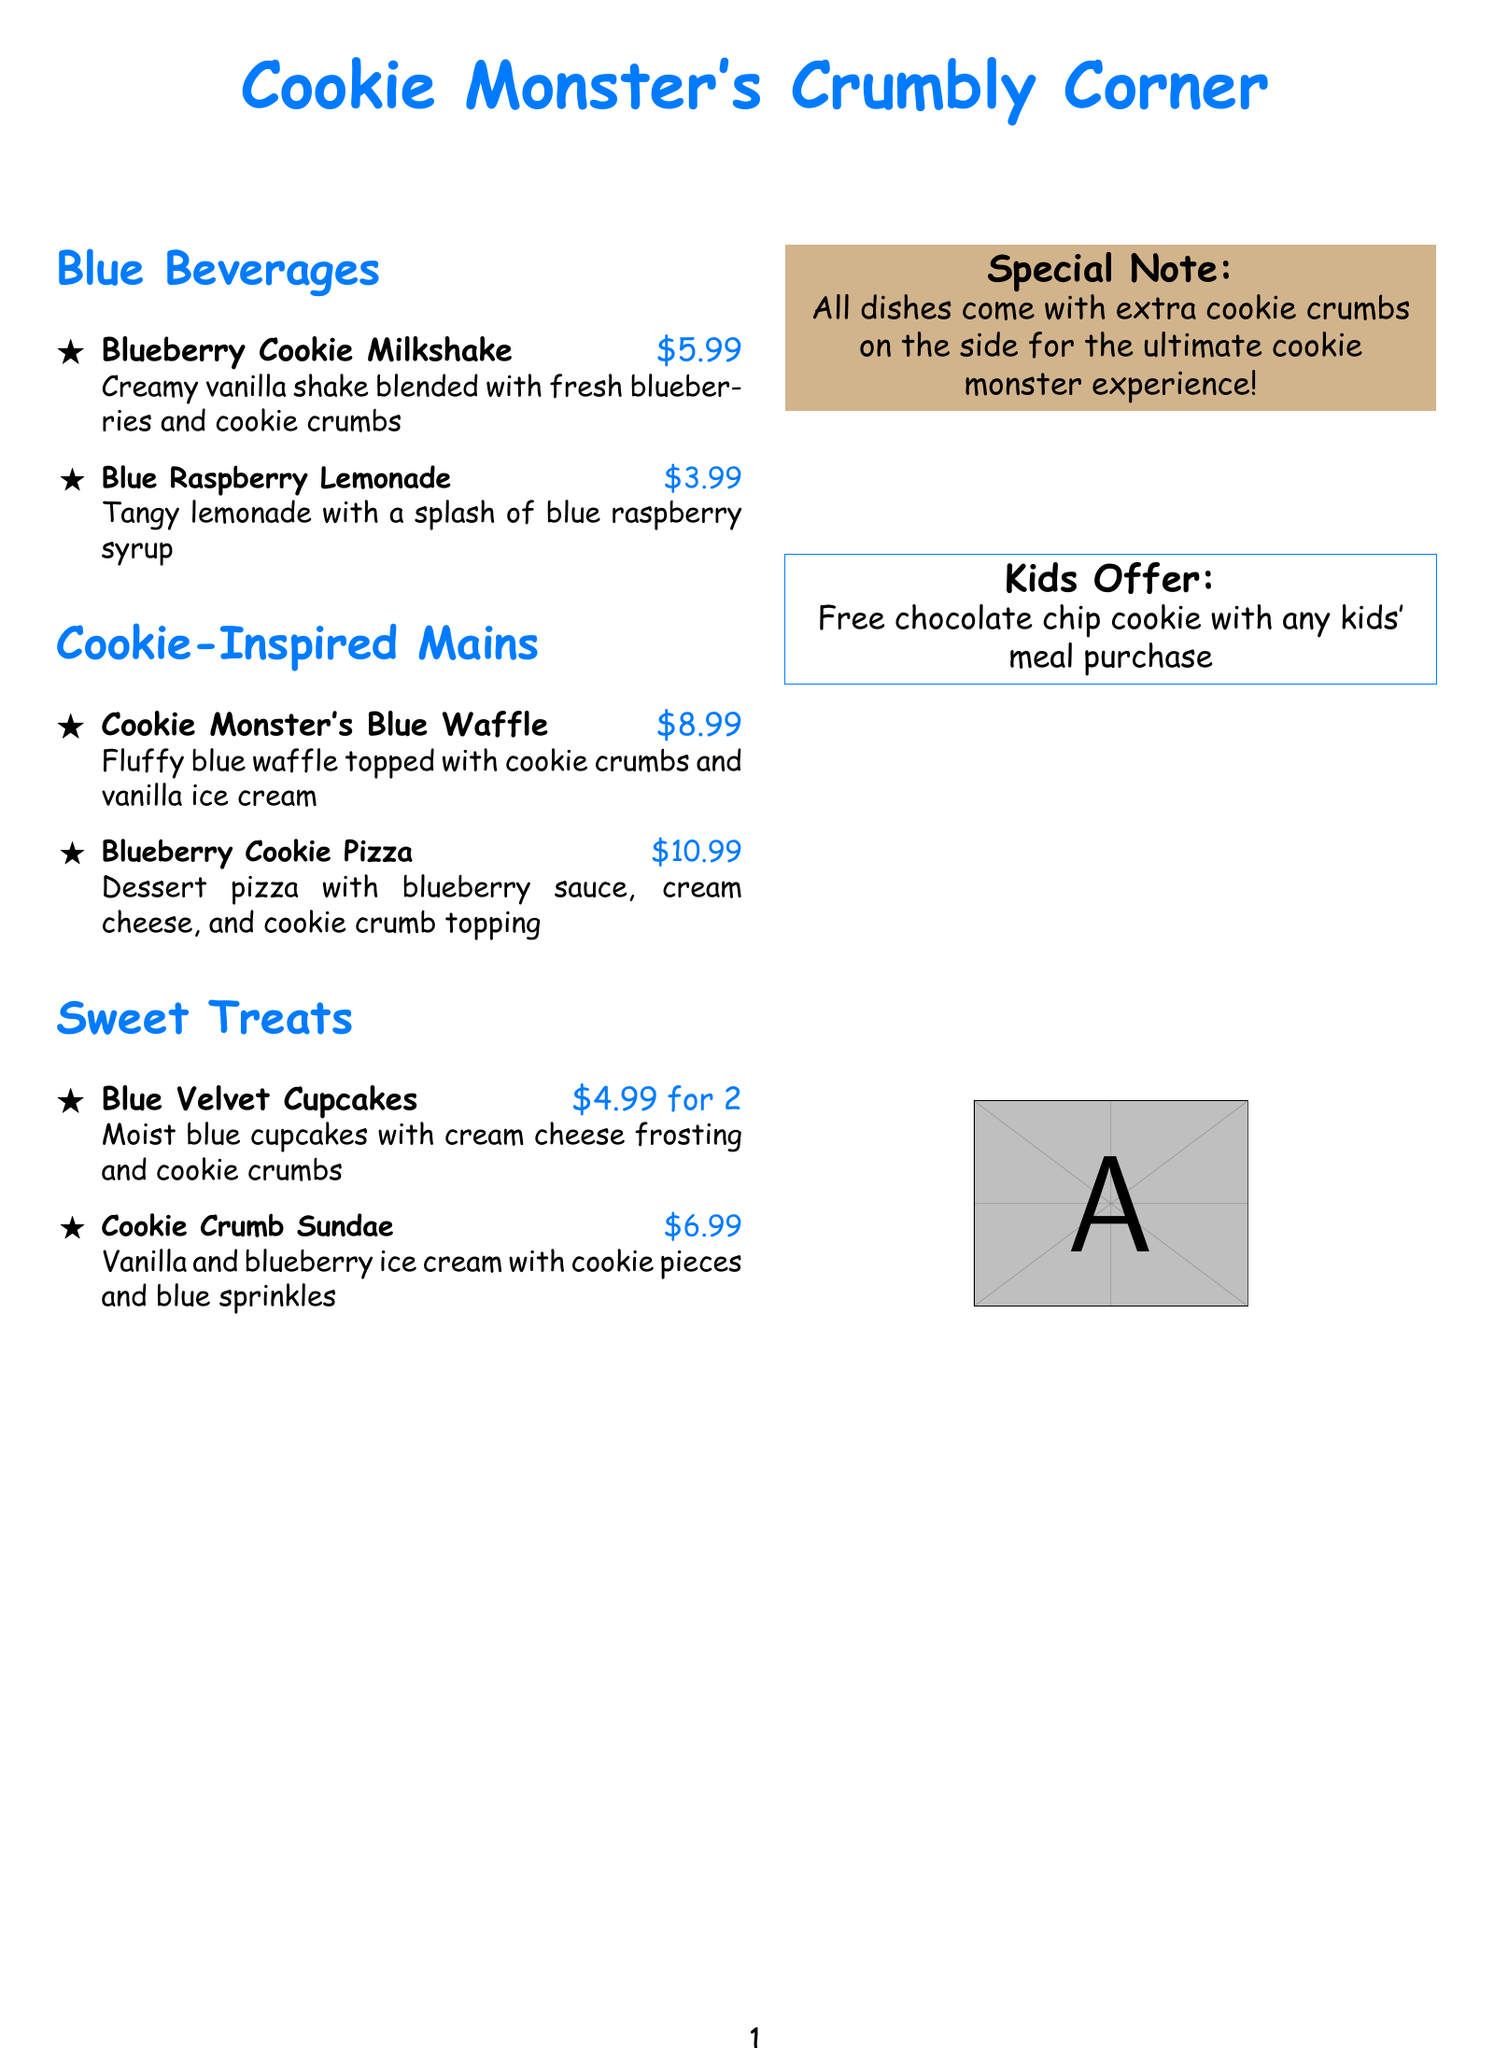What is the title of the menu? The title of the menu is prominently displayed at the top and is given as "Cookie Monster's Crumbly Corner."
Answer: Cookie Monster's Crumbly Corner How much does the Blueberry Cookie Milkshake cost? The price is listed next to the description of the Blueberry Cookie Milkshake in the menu item section.
Answer: $5.99 What color are the beverages on this menu? The section header for the beverages indicates that they are categorized under "Blue Beverages."
Answer: Blue What special note is mentioned in the menu? The special note states that all dishes come with extra cookie crumbs on the side for a better experience.
Answer: Extra cookie crumbs on the side How many Blue Velvet Cupcakes can you get for $4.99? The menu specifically mentions the price for two cupcakes.
Answer: 2 What type of offer is provided for kids on the menu? The menu includes a section specifically stating an offer aimed at kids.
Answer: Free chocolate chip cookie Which dessert includes blueberry sauce? The menu indicates that the item with blueberry sauce is the dessert pizza.
Answer: Blueberry Cookie Pizza What main dish is topped with cookie crumbs and vanilla ice cream? The menu lists the Cookie Monster's Blue Waffle as the main dish with those toppings.
Answer: Cookie Monster's Blue Waffle How much does the Cookie Crumb Sundae cost? The price for the Cookie Crumb Sundae is mentioned in the Sweet Treats section.
Answer: $6.99 